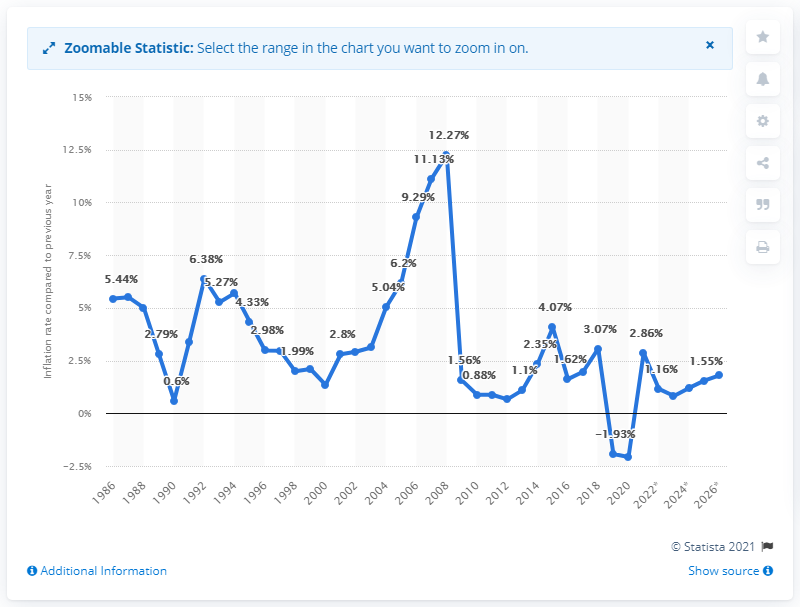Point out several critical features in this image. The inflation rate of the United Arab Emirates in 2022 was 1.2%. 